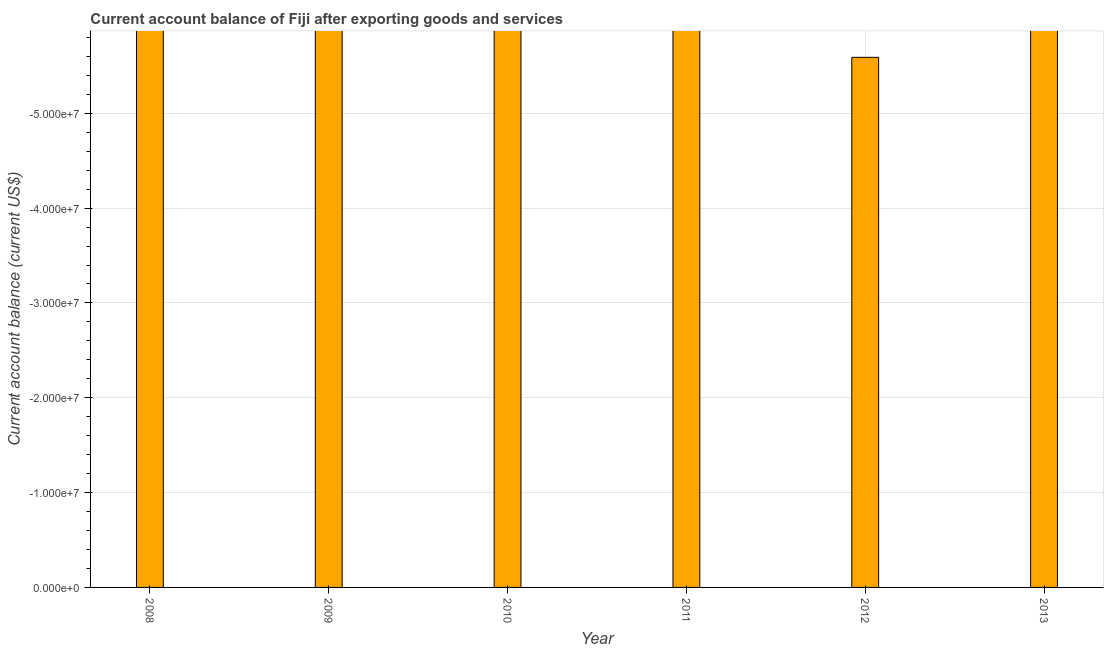Does the graph contain grids?
Your response must be concise. Yes. What is the title of the graph?
Offer a terse response. Current account balance of Fiji after exporting goods and services. What is the label or title of the X-axis?
Provide a short and direct response. Year. What is the label or title of the Y-axis?
Give a very brief answer. Current account balance (current US$). What is the current account balance in 2010?
Offer a very short reply. 0. Across all years, what is the minimum current account balance?
Your answer should be compact. 0. What is the median current account balance?
Provide a succinct answer. 0. In how many years, is the current account balance greater than -48000000 US$?
Give a very brief answer. 0. In how many years, is the current account balance greater than the average current account balance taken over all years?
Provide a short and direct response. 0. How many bars are there?
Ensure brevity in your answer.  0. What is the Current account balance (current US$) in 2010?
Offer a very short reply. 0. What is the Current account balance (current US$) in 2011?
Provide a succinct answer. 0. 